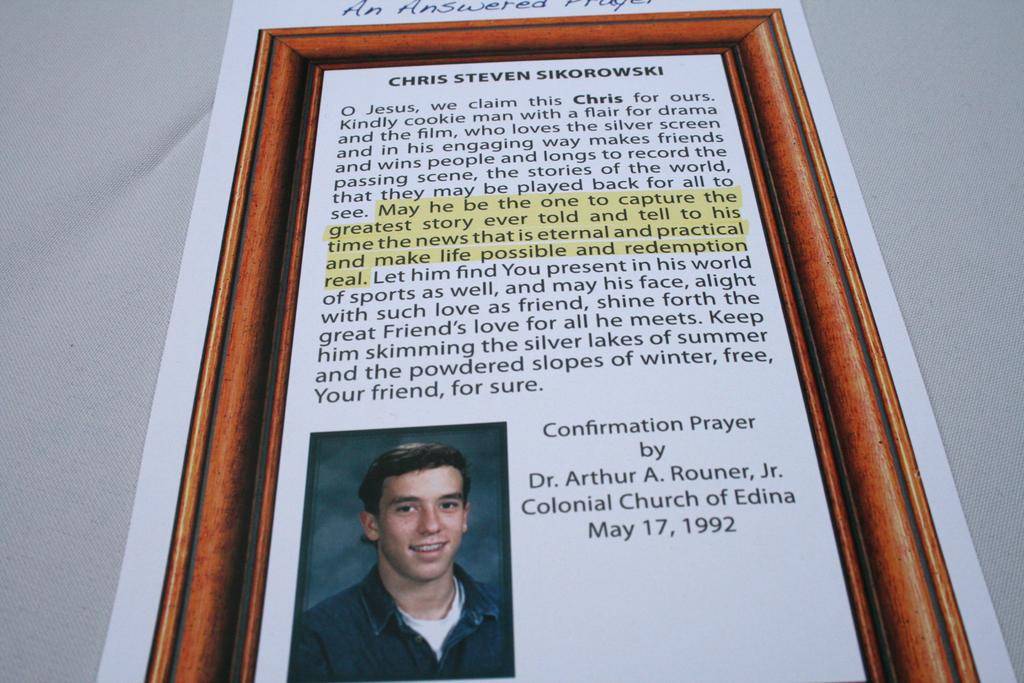What is the main object in the image? There is a frame in the image. What is depicted within the frame? The frame contains a photo of a man. Where is the photo of the man located within the frame? The photo of the man is at the bottom of the frame. What can be found at the top of the frame? There is text at the top of the frame. Are there any bushes growing around the frame in the image? There is no mention of bushes in the provided facts, so we cannot determine if they are present in the image. Does the text at the top of the frame express any feelings of hate? The provided facts do not mention the content of the text, so we cannot determine if it expresses any feelings of hate. 